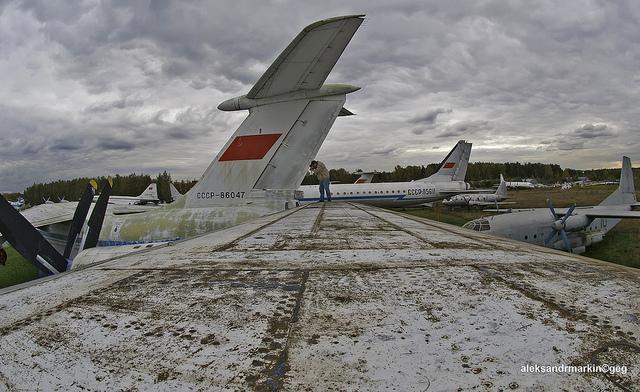How old is the plane?
Quick response, please. Old. Is it about to rain?
Answer briefly. Yes. Is there someone on the plane?
Be succinct. Yes. Why is this plane on display?
Write a very short answer. Old. 